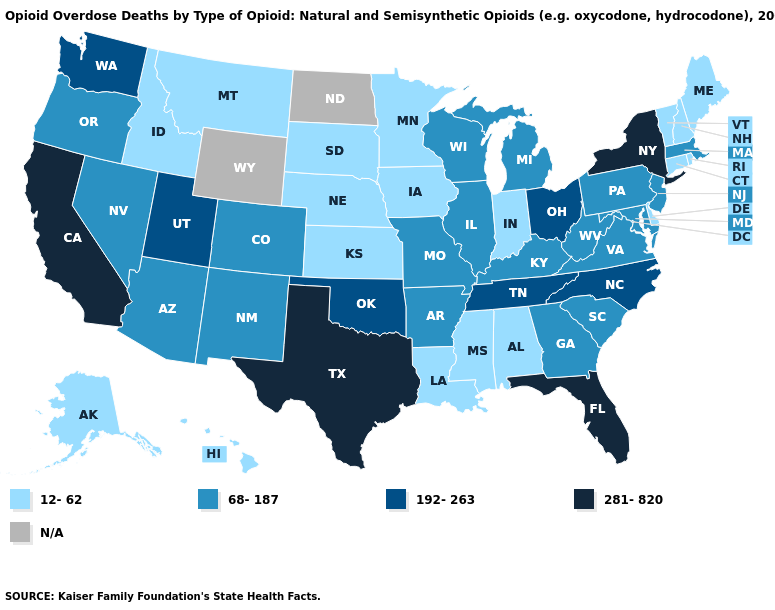Does Massachusetts have the highest value in the USA?
Concise answer only. No. Among the states that border Louisiana , which have the highest value?
Quick response, please. Texas. Which states have the lowest value in the USA?
Be succinct. Alabama, Alaska, Connecticut, Delaware, Hawaii, Idaho, Indiana, Iowa, Kansas, Louisiana, Maine, Minnesota, Mississippi, Montana, Nebraska, New Hampshire, Rhode Island, South Dakota, Vermont. What is the highest value in the USA?
Quick response, please. 281-820. Does Nevada have the lowest value in the USA?
Concise answer only. No. What is the lowest value in the USA?
Be succinct. 12-62. Name the states that have a value in the range N/A?
Write a very short answer. North Dakota, Wyoming. Name the states that have a value in the range 281-820?
Answer briefly. California, Florida, New York, Texas. Does the first symbol in the legend represent the smallest category?
Be succinct. Yes. Which states have the lowest value in the USA?
Give a very brief answer. Alabama, Alaska, Connecticut, Delaware, Hawaii, Idaho, Indiana, Iowa, Kansas, Louisiana, Maine, Minnesota, Mississippi, Montana, Nebraska, New Hampshire, Rhode Island, South Dakota, Vermont. Name the states that have a value in the range 192-263?
Keep it brief. North Carolina, Ohio, Oklahoma, Tennessee, Utah, Washington. Among the states that border Mississippi , does Louisiana have the lowest value?
Keep it brief. Yes. Among the states that border Louisiana , does Arkansas have the highest value?
Write a very short answer. No. 